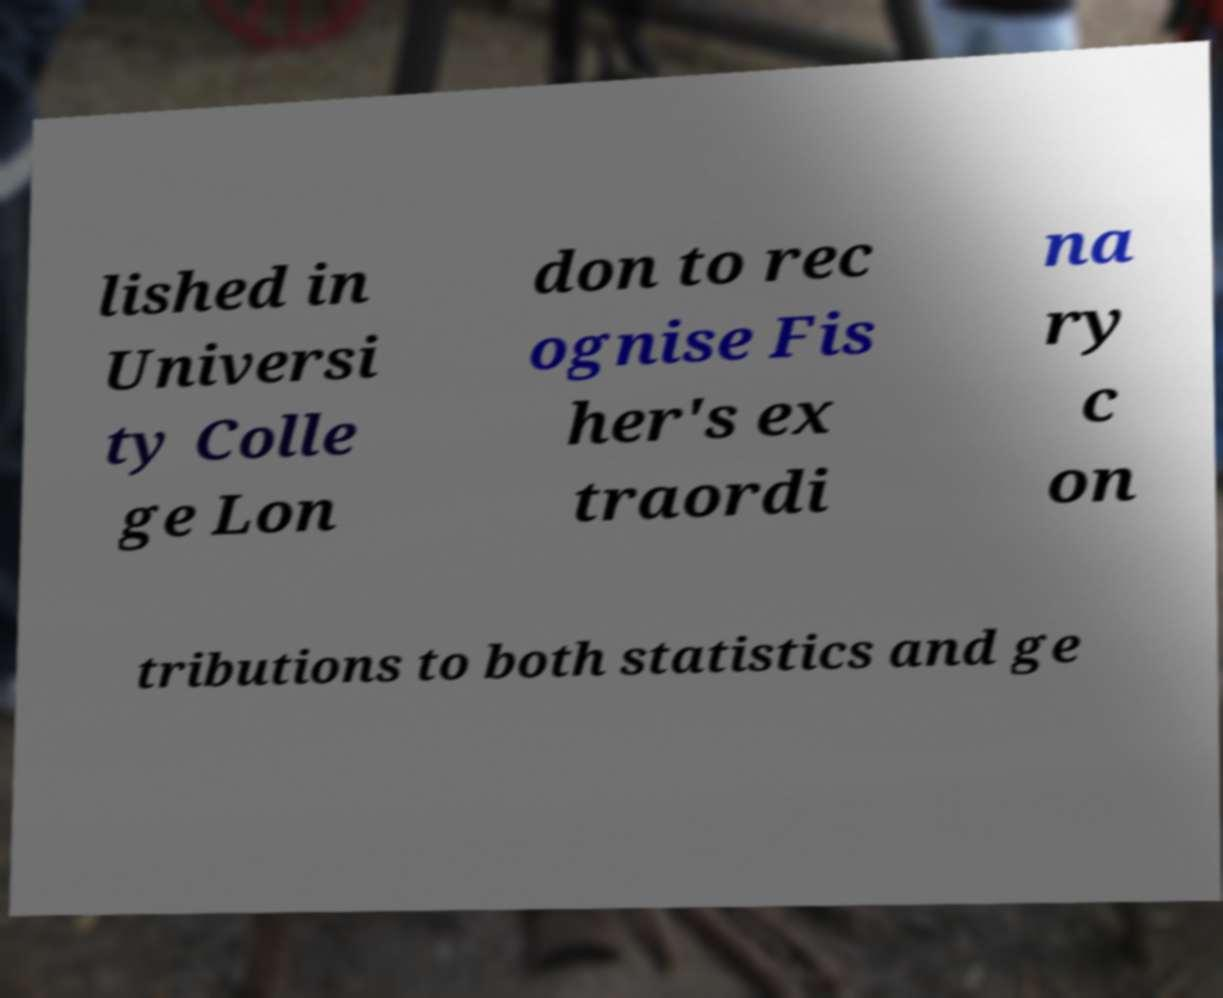Can you read and provide the text displayed in the image?This photo seems to have some interesting text. Can you extract and type it out for me? lished in Universi ty Colle ge Lon don to rec ognise Fis her's ex traordi na ry c on tributions to both statistics and ge 